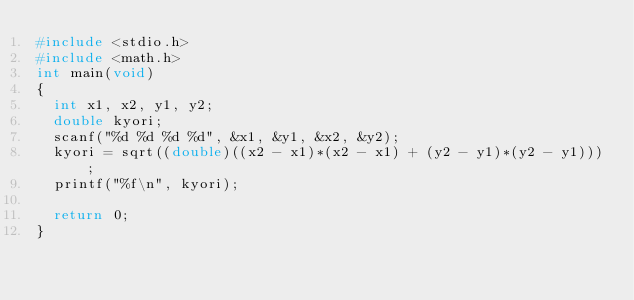<code> <loc_0><loc_0><loc_500><loc_500><_C_>#include <stdio.h> 
#include <math.h>
int main(void)
{
	int x1, x2, y1, y2;
	double kyori;
	scanf("%d %d %d %d", &x1, &y1, &x2, &y2);
	kyori = sqrt((double)((x2 - x1)*(x2 - x1) + (y2 - y1)*(y2 - y1)));
	printf("%f\n", kyori);

	return 0;
}</code> 